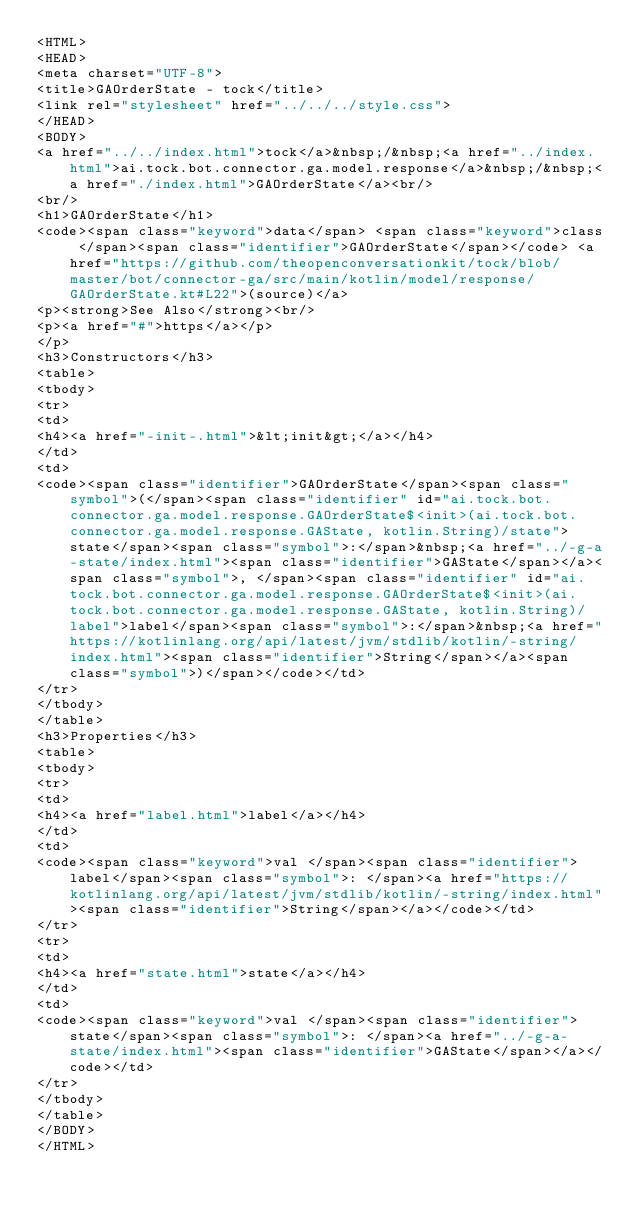Convert code to text. <code><loc_0><loc_0><loc_500><loc_500><_HTML_><HTML>
<HEAD>
<meta charset="UTF-8">
<title>GAOrderState - tock</title>
<link rel="stylesheet" href="../../../style.css">
</HEAD>
<BODY>
<a href="../../index.html">tock</a>&nbsp;/&nbsp;<a href="../index.html">ai.tock.bot.connector.ga.model.response</a>&nbsp;/&nbsp;<a href="./index.html">GAOrderState</a><br/>
<br/>
<h1>GAOrderState</h1>
<code><span class="keyword">data</span> <span class="keyword">class </span><span class="identifier">GAOrderState</span></code> <a href="https://github.com/theopenconversationkit/tock/blob/master/bot/connector-ga/src/main/kotlin/model/response/GAOrderState.kt#L22">(source)</a>
<p><strong>See Also</strong><br/>
<p><a href="#">https</a></p>
</p>
<h3>Constructors</h3>
<table>
<tbody>
<tr>
<td>
<h4><a href="-init-.html">&lt;init&gt;</a></h4>
</td>
<td>
<code><span class="identifier">GAOrderState</span><span class="symbol">(</span><span class="identifier" id="ai.tock.bot.connector.ga.model.response.GAOrderState$<init>(ai.tock.bot.connector.ga.model.response.GAState, kotlin.String)/state">state</span><span class="symbol">:</span>&nbsp;<a href="../-g-a-state/index.html"><span class="identifier">GAState</span></a><span class="symbol">, </span><span class="identifier" id="ai.tock.bot.connector.ga.model.response.GAOrderState$<init>(ai.tock.bot.connector.ga.model.response.GAState, kotlin.String)/label">label</span><span class="symbol">:</span>&nbsp;<a href="https://kotlinlang.org/api/latest/jvm/stdlib/kotlin/-string/index.html"><span class="identifier">String</span></a><span class="symbol">)</span></code></td>
</tr>
</tbody>
</table>
<h3>Properties</h3>
<table>
<tbody>
<tr>
<td>
<h4><a href="label.html">label</a></h4>
</td>
<td>
<code><span class="keyword">val </span><span class="identifier">label</span><span class="symbol">: </span><a href="https://kotlinlang.org/api/latest/jvm/stdlib/kotlin/-string/index.html"><span class="identifier">String</span></a></code></td>
</tr>
<tr>
<td>
<h4><a href="state.html">state</a></h4>
</td>
<td>
<code><span class="keyword">val </span><span class="identifier">state</span><span class="symbol">: </span><a href="../-g-a-state/index.html"><span class="identifier">GAState</span></a></code></td>
</tr>
</tbody>
</table>
</BODY>
</HTML>
</code> 